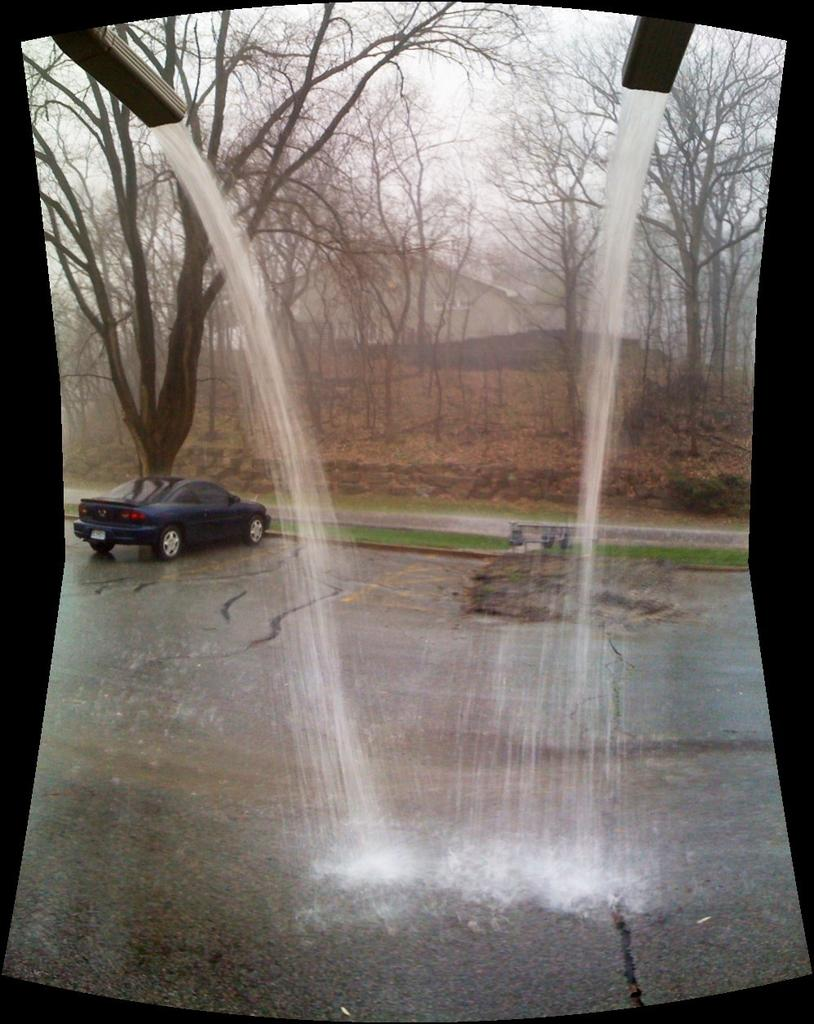What color is the car in the image? The car in the image is blue. What can be seen in the background of the image? There are trees in the background of the image. What type of vegetation is visible in the image? There is grass visible in the image. What else is visible in the image besides the car and vegetation? There is water visible in the image. What is visible at the top of the image? The sky is visible at the top of the image. What type of canvas is being used to paint the aftermath of the building collapse in the image? There is no canvas or building collapse present in the image; it features a blue car, trees, grass, water, and the sky. 